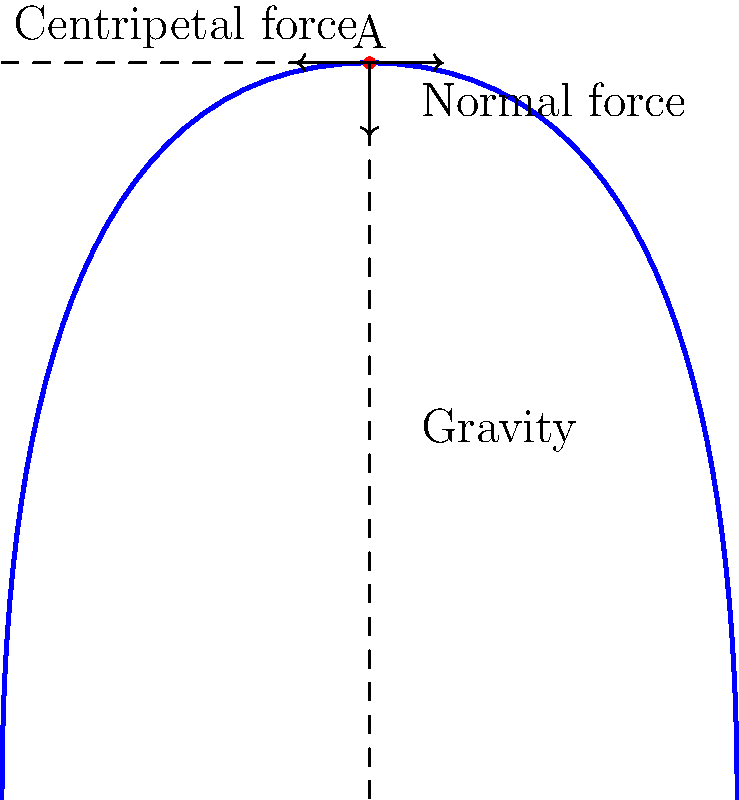At La Ronde amusement park, you're enjoying a thrilling ride on the Goliath roller coaster. As your car reaches the top of a circular loop (point A in the diagram), which force(s) act on you, and what is their primary purpose at this moment? Let's break down the forces acting on you at the top of the loop (point A):

1. Gravity: This force always pulls you towards the center of the Earth. It's constant and doesn't change based on your position on the track.

2. Normal force: This is the force exerted by the track on you, perpendicular to the track's surface. At the top of the loop, it points downward, opposite to gravity.

3. Centripetal force: This is not a separate force, but rather the net force that keeps you moving in a circular path. At the top of the loop, it's the difference between gravity and the normal force.

The primary purpose of these forces at this moment is to keep you moving in a circular path. Here's how they work together:

- Gravity pulls you down, which helps you complete the loop.
- The normal force from the track prevents you from falling through the track.
- The difference between these forces (gravity minus normal force) provides the centripetal force needed to keep you moving in a circular path.

The key is that at the top of the loop, the normal force is less than your weight (gravity), allowing you to complete the loop without falling off the track.
Answer: Gravity and normal force act on you, providing the centripetal force to maintain circular motion. 